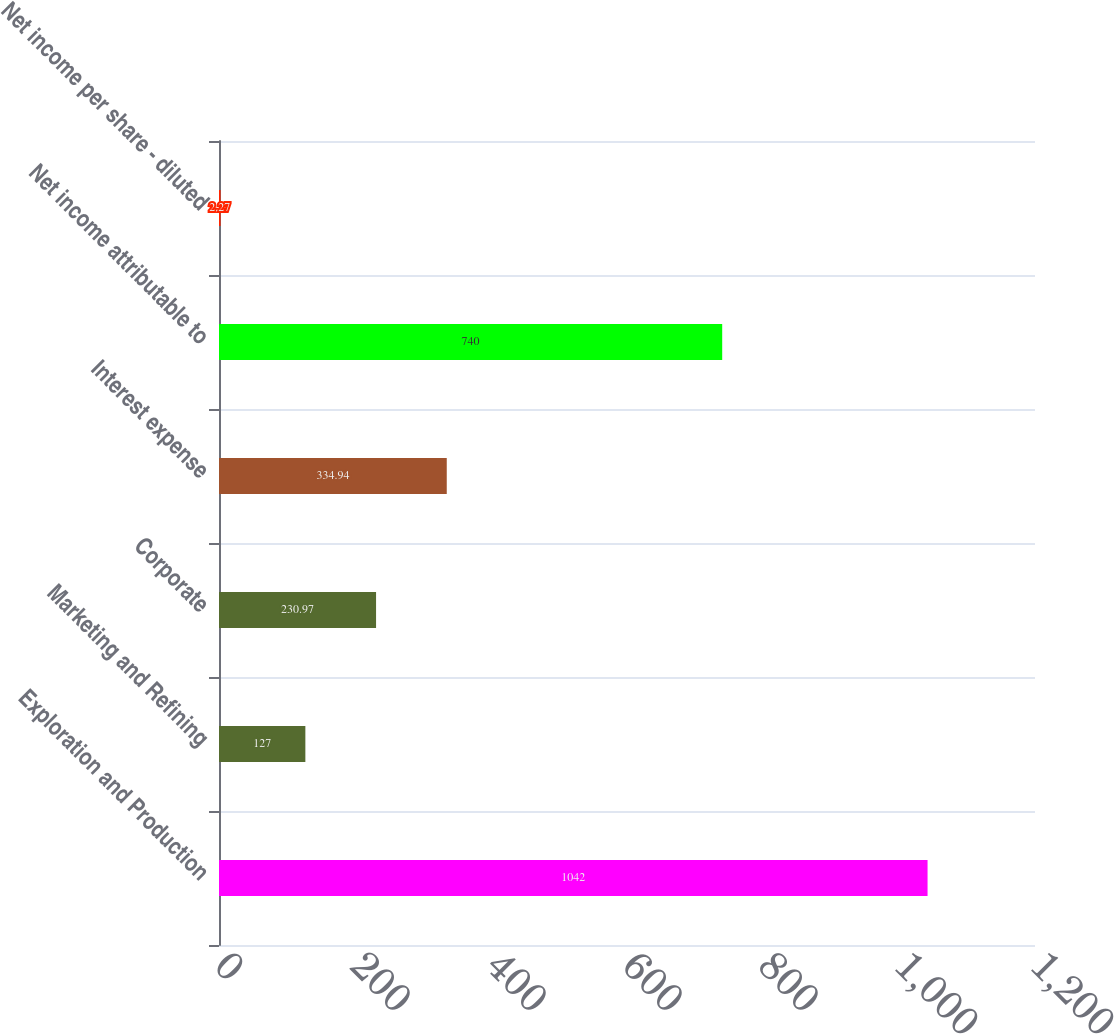Convert chart to OTSL. <chart><loc_0><loc_0><loc_500><loc_500><bar_chart><fcel>Exploration and Production<fcel>Marketing and Refining<fcel>Corporate<fcel>Interest expense<fcel>Net income attributable to<fcel>Net income per share - diluted<nl><fcel>1042<fcel>127<fcel>230.97<fcel>334.94<fcel>740<fcel>2.27<nl></chart> 